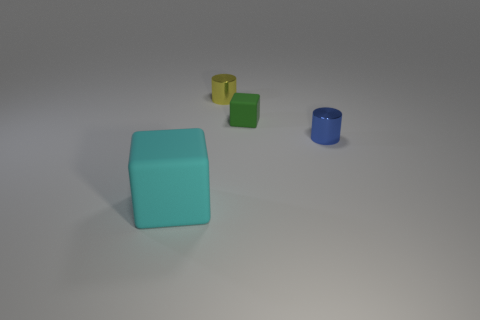Subtract all green cubes. How many cubes are left? 1 Subtract 2 blocks. How many blocks are left? 0 Add 1 cyan objects. How many objects exist? 5 Subtract all brown cylinders. How many red cubes are left? 0 Subtract all gray cylinders. Subtract all green spheres. How many cylinders are left? 2 Subtract all large red things. Subtract all small matte objects. How many objects are left? 3 Add 4 yellow shiny things. How many yellow shiny things are left? 5 Add 4 brown objects. How many brown objects exist? 4 Subtract 0 blue cubes. How many objects are left? 4 